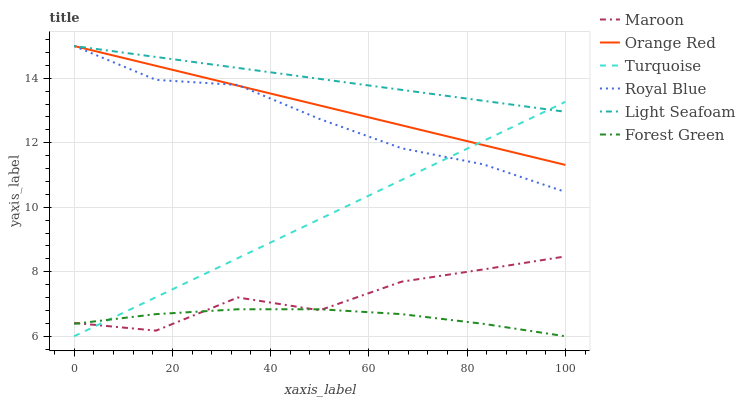Does Maroon have the minimum area under the curve?
Answer yes or no. No. Does Maroon have the maximum area under the curve?
Answer yes or no. No. Is Royal Blue the smoothest?
Answer yes or no. No. Is Royal Blue the roughest?
Answer yes or no. No. Does Maroon have the lowest value?
Answer yes or no. No. Does Maroon have the highest value?
Answer yes or no. No. Is Forest Green less than Orange Red?
Answer yes or no. Yes. Is Light Seafoam greater than Forest Green?
Answer yes or no. Yes. Does Forest Green intersect Orange Red?
Answer yes or no. No. 